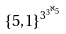Convert formula to latex. <formula><loc_0><loc_0><loc_500><loc_500>\{ 5 , 1 \} ^ { 3 ^ { 3 ^ { \aleph _ { 5 } } } }</formula> 